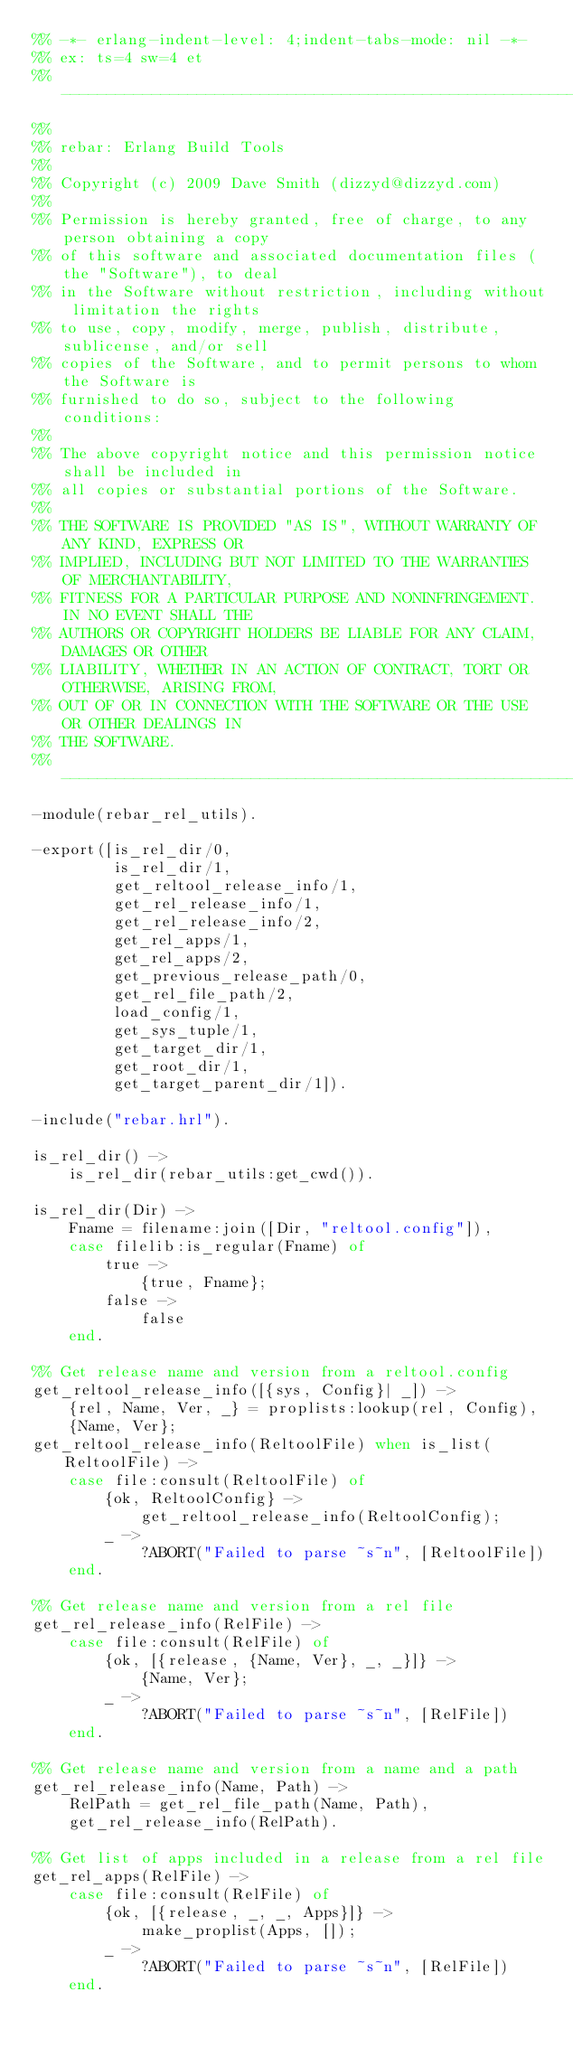<code> <loc_0><loc_0><loc_500><loc_500><_Erlang_>%% -*- erlang-indent-level: 4;indent-tabs-mode: nil -*-
%% ex: ts=4 sw=4 et
%% -------------------------------------------------------------------
%%
%% rebar: Erlang Build Tools
%%
%% Copyright (c) 2009 Dave Smith (dizzyd@dizzyd.com)
%%
%% Permission is hereby granted, free of charge, to any person obtaining a copy
%% of this software and associated documentation files (the "Software"), to deal
%% in the Software without restriction, including without limitation the rights
%% to use, copy, modify, merge, publish, distribute, sublicense, and/or sell
%% copies of the Software, and to permit persons to whom the Software is
%% furnished to do so, subject to the following conditions:
%%
%% The above copyright notice and this permission notice shall be included in
%% all copies or substantial portions of the Software.
%%
%% THE SOFTWARE IS PROVIDED "AS IS", WITHOUT WARRANTY OF ANY KIND, EXPRESS OR
%% IMPLIED, INCLUDING BUT NOT LIMITED TO THE WARRANTIES OF MERCHANTABILITY,
%% FITNESS FOR A PARTICULAR PURPOSE AND NONINFRINGEMENT. IN NO EVENT SHALL THE
%% AUTHORS OR COPYRIGHT HOLDERS BE LIABLE FOR ANY CLAIM, DAMAGES OR OTHER
%% LIABILITY, WHETHER IN AN ACTION OF CONTRACT, TORT OR OTHERWISE, ARISING FROM,
%% OUT OF OR IN CONNECTION WITH THE SOFTWARE OR THE USE OR OTHER DEALINGS IN
%% THE SOFTWARE.
%% -------------------------------------------------------------------
-module(rebar_rel_utils).

-export([is_rel_dir/0,
         is_rel_dir/1,
         get_reltool_release_info/1,
         get_rel_release_info/1,
         get_rel_release_info/2,
         get_rel_apps/1,
         get_rel_apps/2,
         get_previous_release_path/0,
         get_rel_file_path/2,
         load_config/1,
         get_sys_tuple/1,
         get_target_dir/1,
         get_root_dir/1,
         get_target_parent_dir/1]).

-include("rebar.hrl").

is_rel_dir() ->
    is_rel_dir(rebar_utils:get_cwd()).

is_rel_dir(Dir) ->
    Fname = filename:join([Dir, "reltool.config"]),
    case filelib:is_regular(Fname) of
        true ->
            {true, Fname};
        false ->
            false
    end.

%% Get release name and version from a reltool.config
get_reltool_release_info([{sys, Config}| _]) ->
    {rel, Name, Ver, _} = proplists:lookup(rel, Config),
    {Name, Ver};
get_reltool_release_info(ReltoolFile) when is_list(ReltoolFile) ->
    case file:consult(ReltoolFile) of
        {ok, ReltoolConfig} ->
            get_reltool_release_info(ReltoolConfig);
        _ ->
            ?ABORT("Failed to parse ~s~n", [ReltoolFile])
    end.

%% Get release name and version from a rel file
get_rel_release_info(RelFile) ->
    case file:consult(RelFile) of
        {ok, [{release, {Name, Ver}, _, _}]} ->
            {Name, Ver};
        _ ->
            ?ABORT("Failed to parse ~s~n", [RelFile])
    end.

%% Get release name and version from a name and a path
get_rel_release_info(Name, Path) ->
    RelPath = get_rel_file_path(Name, Path),
    get_rel_release_info(RelPath).

%% Get list of apps included in a release from a rel file
get_rel_apps(RelFile) ->
    case file:consult(RelFile) of
        {ok, [{release, _, _, Apps}]} ->
            make_proplist(Apps, []);
        _ ->
            ?ABORT("Failed to parse ~s~n", [RelFile])
    end.
</code> 